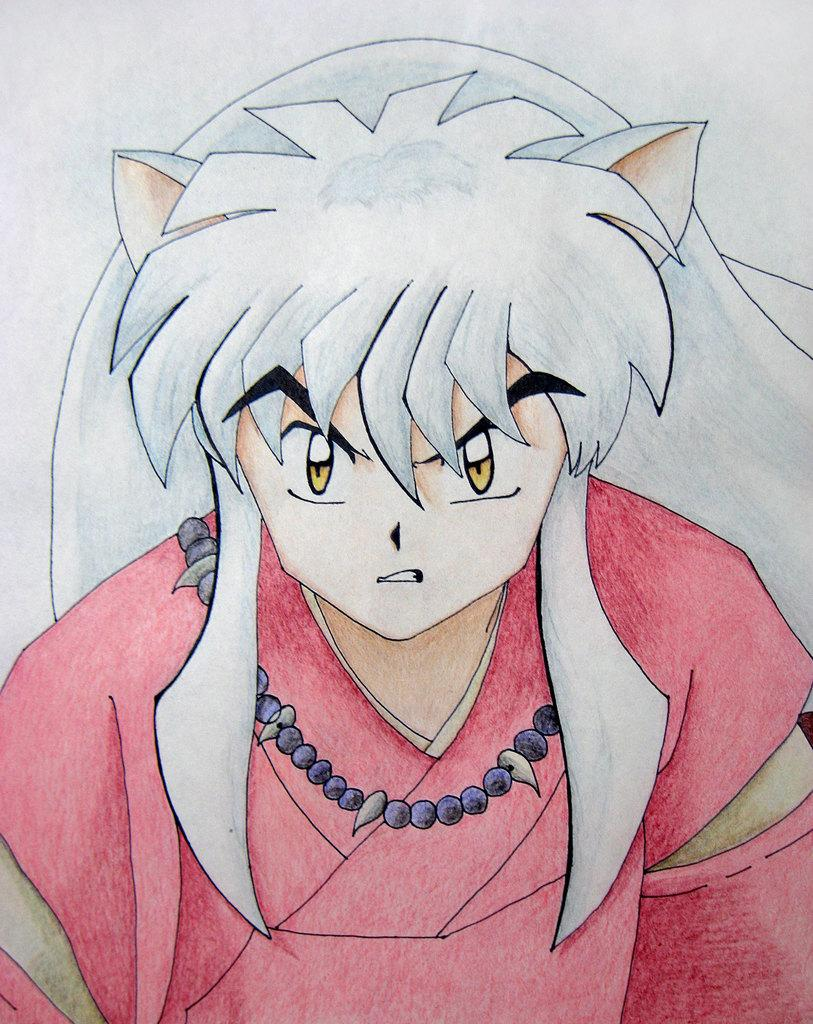What is the main subject of the image? The main subject of the image is a drawing. What type of mint can be seen in the image? There is no mint present in the image; it only features a drawing. What caption is written below the drawing in the image? There is no caption visible in the image; it only features a drawing. 